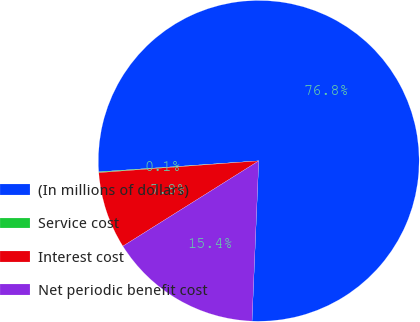Convert chart to OTSL. <chart><loc_0><loc_0><loc_500><loc_500><pie_chart><fcel>(In millions of dollars)<fcel>Service cost<fcel>Interest cost<fcel>Net periodic benefit cost<nl><fcel>76.76%<fcel>0.08%<fcel>7.75%<fcel>15.41%<nl></chart> 